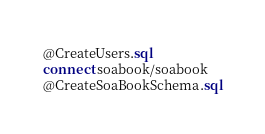Convert code to text. <code><loc_0><loc_0><loc_500><loc_500><_SQL_>@CreateUsers.sql
connect soabook/soabook
@CreateSoaBookSchema.sql</code> 